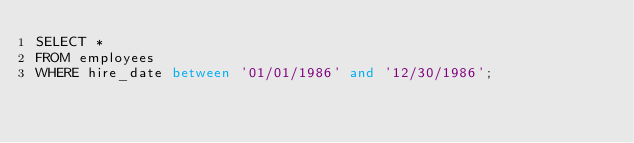Convert code to text. <code><loc_0><loc_0><loc_500><loc_500><_SQL_>SELECT *
FROM employees
WHERE hire_date between '01/01/1986' and '12/30/1986';
</code> 